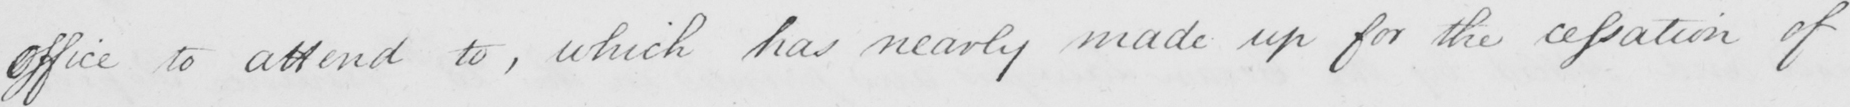What text is written in this handwritten line? office to attend to , which has nearly made up for the cessation of 